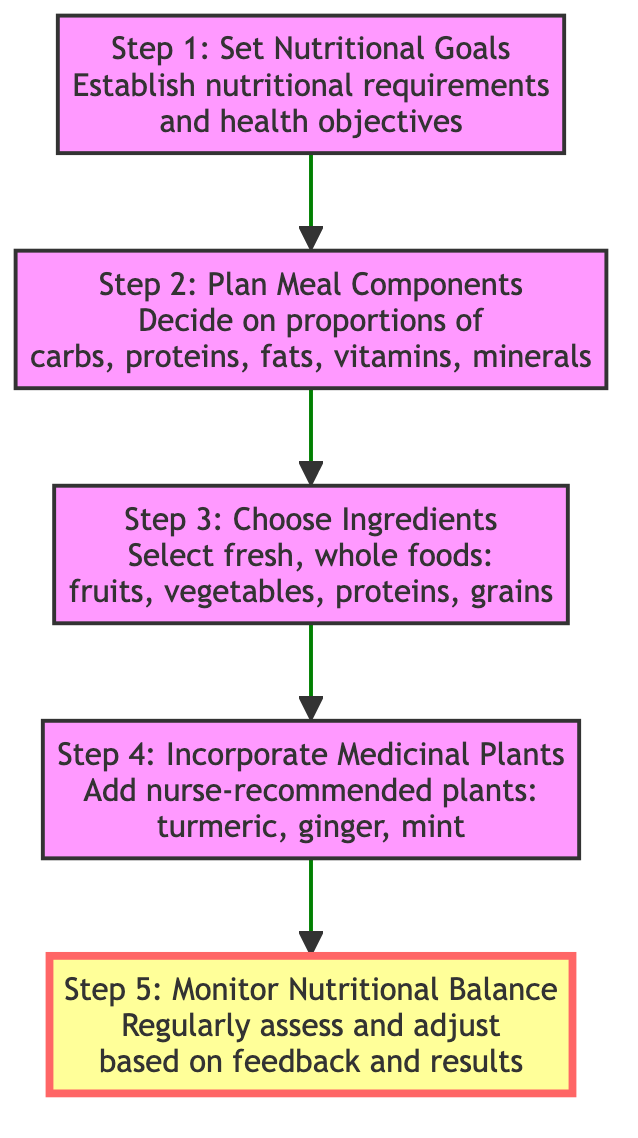What is the first step in the meal planning process? The diagram indicates that the first step is to "Set Nutritional Goals," which includes establishing nutritional requirements and health objectives.
Answer: Set Nutritional Goals How many steps are there in the flow chart? By counting the nodes in the diagram, we can see that there are a total of five steps.
Answer: 5 What is the last step to be taken according to the diagram? The final step is "Monitor Nutritional Balance," which involves assessing and adjusting the meal plan based on feedback and results.
Answer: Monitor Nutritional Balance Which step follows "Choose Ingredients"? The next step after "Choose Ingredients" is "Incorporate Medicinal Plants," as indicated by the arrows connecting these steps.
Answer: Incorporate Medicinal Plants What do you do in "Step 2"? In "Step 2: Plan Meal Components," the action involves deciding on the proportions of carbohydrates, proteins, fats, vitamins, and minerals needed for each meal.
Answer: Decide on proportions What are two examples of medicinal plants mentioned in the diagram? The diagram specifies "turmeric" and "ginger" as examples of nurse-recommended medicinal plants to be incorporated into meals.
Answer: turmeric, ginger What relationships exist between "Set Nutritional Goals" and "Monitor Nutritional Balance"? "Set Nutritional Goals" is the first step leading to "Plan Meal Components," which eventually culminates in "Monitor Nutritional Balance," indicating a sequential relationship between setting goals and evaluating outcomes.
Answer: Sequential relationship What is emphasized in the last step of the flow chart? The last step emphasizes the importance of regular assessment and adjustments to ensure the meal plan remains nutritionally balanced based on feedback and results.
Answer: Regular assessment and adjustments What type of foods should be selected in "Step 3"? In "Step 3: Choose Ingredients," it specifies selecting a variety of fresh, whole foods, including fruits, vegetables, proteins, and grains, to create a balanced meal plan.
Answer: Fresh, whole foods 